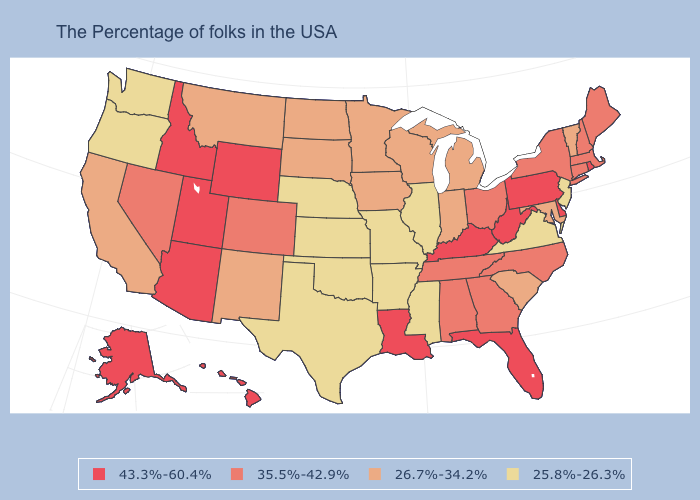What is the lowest value in the USA?
Concise answer only. 25.8%-26.3%. What is the value of Oklahoma?
Be succinct. 25.8%-26.3%. Does the map have missing data?
Short answer required. No. Name the states that have a value in the range 26.7%-34.2%?
Concise answer only. Vermont, Maryland, South Carolina, Michigan, Indiana, Wisconsin, Minnesota, Iowa, South Dakota, North Dakota, New Mexico, Montana, California. What is the lowest value in the West?
Answer briefly. 25.8%-26.3%. Name the states that have a value in the range 35.5%-42.9%?
Keep it brief. Maine, Massachusetts, New Hampshire, Connecticut, New York, North Carolina, Ohio, Georgia, Alabama, Tennessee, Colorado, Nevada. What is the lowest value in the USA?
Keep it brief. 25.8%-26.3%. What is the value of Illinois?
Quick response, please. 25.8%-26.3%. Does Ohio have the highest value in the MidWest?
Concise answer only. Yes. Name the states that have a value in the range 25.8%-26.3%?
Answer briefly. New Jersey, Virginia, Illinois, Mississippi, Missouri, Arkansas, Kansas, Nebraska, Oklahoma, Texas, Washington, Oregon. What is the value of New Hampshire?
Concise answer only. 35.5%-42.9%. Among the states that border Michigan , does Indiana have the highest value?
Quick response, please. No. Does the map have missing data?
Quick response, please. No. Name the states that have a value in the range 25.8%-26.3%?
Give a very brief answer. New Jersey, Virginia, Illinois, Mississippi, Missouri, Arkansas, Kansas, Nebraska, Oklahoma, Texas, Washington, Oregon. Is the legend a continuous bar?
Keep it brief. No. 